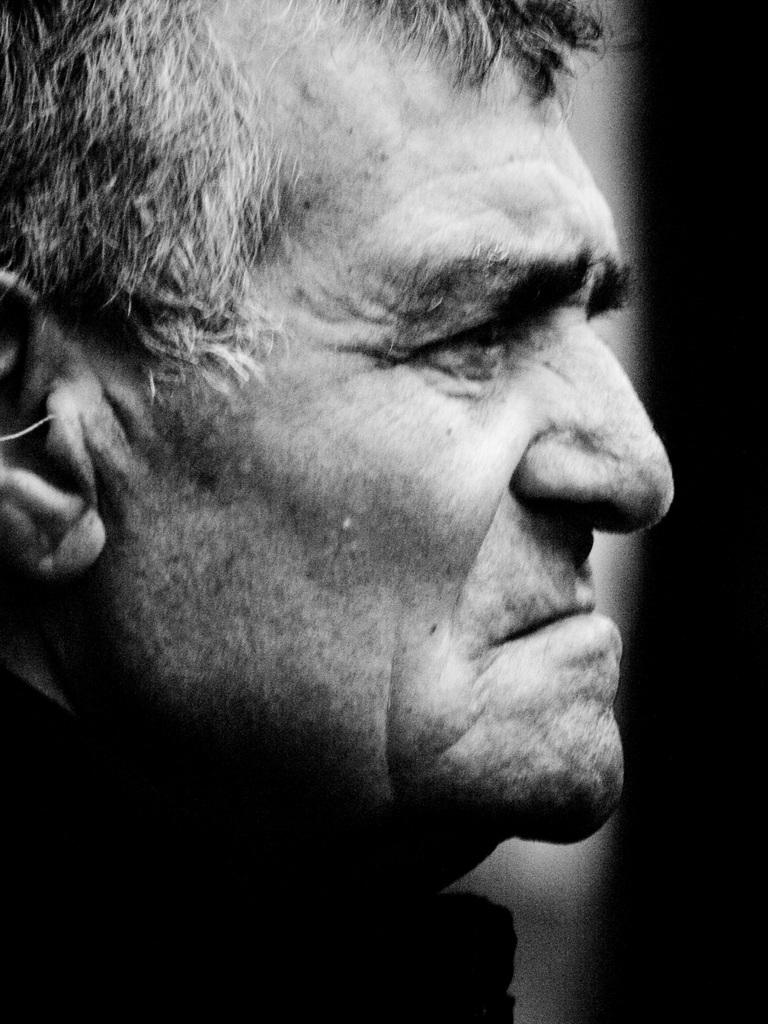What is the color scheme of the image? The image is black and white. Who or what is the main subject in the image? There is a man in the center of the image. How would you describe the lighting on the right side of the image? The right side of the image is dark. What type of quilt is draped over the man's shoulders in the image? There is no quilt present in the image; it is a black and white photograph of a man. What material is the silk scarf made of that the man is wearing in the image? There is no scarf, let alone a silk one, visible in the image. 